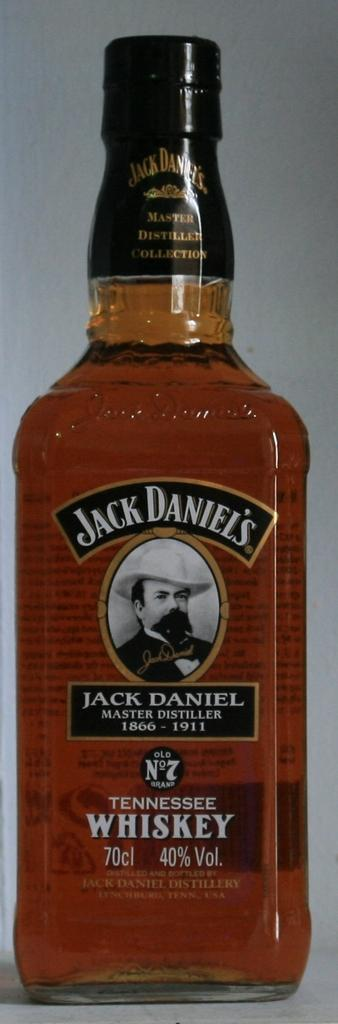<image>
Give a short and clear explanation of the subsequent image. A bottle full of a gold drink is labeled Jack Daniels. 